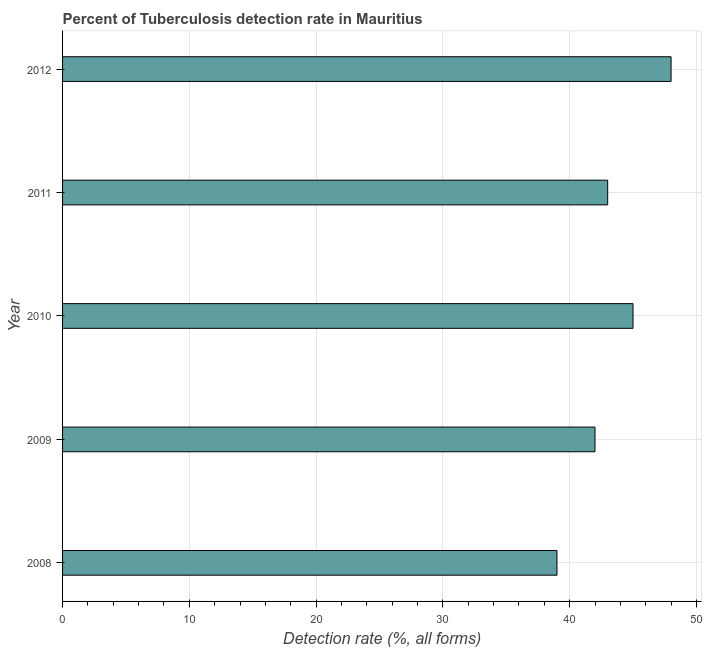Does the graph contain any zero values?
Your response must be concise. No. Does the graph contain grids?
Your answer should be compact. Yes. What is the title of the graph?
Keep it short and to the point. Percent of Tuberculosis detection rate in Mauritius. What is the label or title of the X-axis?
Give a very brief answer. Detection rate (%, all forms). Across all years, what is the minimum detection rate of tuberculosis?
Your answer should be very brief. 39. In which year was the detection rate of tuberculosis minimum?
Offer a terse response. 2008. What is the sum of the detection rate of tuberculosis?
Your response must be concise. 217. What is the difference between the detection rate of tuberculosis in 2008 and 2010?
Provide a short and direct response. -6. What is the average detection rate of tuberculosis per year?
Provide a short and direct response. 43. What is the median detection rate of tuberculosis?
Make the answer very short. 43. In how many years, is the detection rate of tuberculosis greater than 30 %?
Ensure brevity in your answer.  5. What is the ratio of the detection rate of tuberculosis in 2008 to that in 2012?
Your answer should be compact. 0.81. Is the sum of the detection rate of tuberculosis in 2008 and 2012 greater than the maximum detection rate of tuberculosis across all years?
Your answer should be very brief. Yes. How many bars are there?
Keep it short and to the point. 5. Are all the bars in the graph horizontal?
Make the answer very short. Yes. What is the difference between two consecutive major ticks on the X-axis?
Your answer should be compact. 10. Are the values on the major ticks of X-axis written in scientific E-notation?
Offer a very short reply. No. What is the Detection rate (%, all forms) of 2008?
Provide a succinct answer. 39. What is the Detection rate (%, all forms) of 2009?
Ensure brevity in your answer.  42. What is the Detection rate (%, all forms) of 2010?
Give a very brief answer. 45. What is the difference between the Detection rate (%, all forms) in 2008 and 2009?
Make the answer very short. -3. What is the difference between the Detection rate (%, all forms) in 2008 and 2011?
Your response must be concise. -4. What is the difference between the Detection rate (%, all forms) in 2009 and 2010?
Offer a very short reply. -3. What is the difference between the Detection rate (%, all forms) in 2009 and 2011?
Keep it short and to the point. -1. What is the difference between the Detection rate (%, all forms) in 2009 and 2012?
Provide a short and direct response. -6. What is the difference between the Detection rate (%, all forms) in 2010 and 2011?
Give a very brief answer. 2. What is the difference between the Detection rate (%, all forms) in 2010 and 2012?
Make the answer very short. -3. What is the difference between the Detection rate (%, all forms) in 2011 and 2012?
Keep it short and to the point. -5. What is the ratio of the Detection rate (%, all forms) in 2008 to that in 2009?
Make the answer very short. 0.93. What is the ratio of the Detection rate (%, all forms) in 2008 to that in 2010?
Give a very brief answer. 0.87. What is the ratio of the Detection rate (%, all forms) in 2008 to that in 2011?
Your answer should be very brief. 0.91. What is the ratio of the Detection rate (%, all forms) in 2008 to that in 2012?
Your answer should be compact. 0.81. What is the ratio of the Detection rate (%, all forms) in 2009 to that in 2010?
Ensure brevity in your answer.  0.93. What is the ratio of the Detection rate (%, all forms) in 2010 to that in 2011?
Offer a terse response. 1.05. What is the ratio of the Detection rate (%, all forms) in 2010 to that in 2012?
Offer a terse response. 0.94. What is the ratio of the Detection rate (%, all forms) in 2011 to that in 2012?
Offer a very short reply. 0.9. 